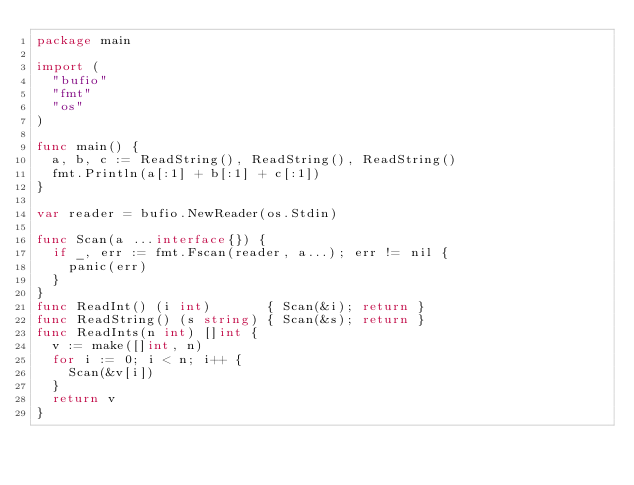Convert code to text. <code><loc_0><loc_0><loc_500><loc_500><_Go_>package main

import (
	"bufio"
	"fmt"
	"os"
)

func main() {
	a, b, c := ReadString(), ReadString(), ReadString()
	fmt.Println(a[:1] + b[:1] + c[:1])
}

var reader = bufio.NewReader(os.Stdin)

func Scan(a ...interface{}) {
	if _, err := fmt.Fscan(reader, a...); err != nil {
		panic(err)
	}
}
func ReadInt() (i int)       { Scan(&i); return }
func ReadString() (s string) { Scan(&s); return }
func ReadInts(n int) []int {
	v := make([]int, n)
	for i := 0; i < n; i++ {
		Scan(&v[i])
	}
	return v
}
</code> 